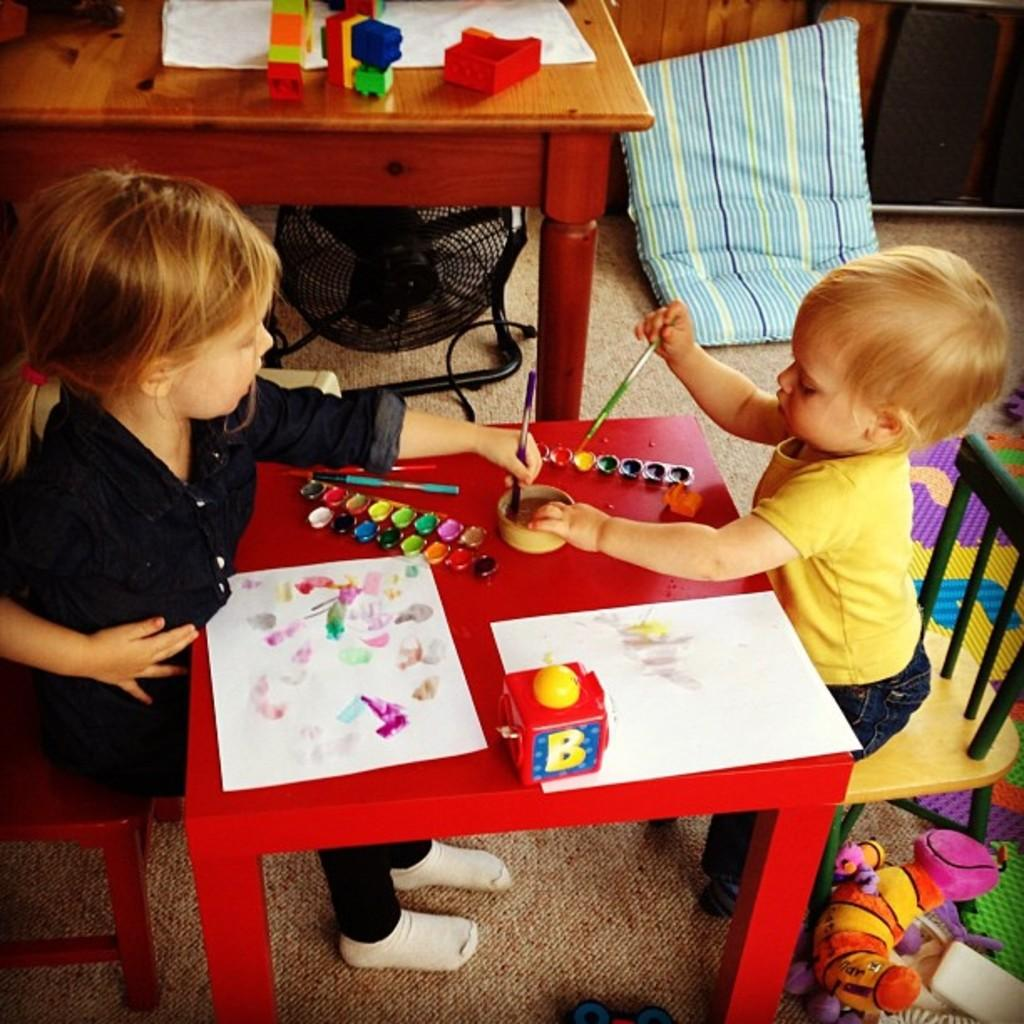What object can be seen on the floor in the image? There is a pillow on the floor in the image. What piece of furniture is present in the image? There is a table in the image. How many people are sitting in the image? There are two people sitting on chairs in the image. What is on top of the table in the image? There is a box and a paper on the table in the image. What can be observed about the table in the image? There are colors on the table in the image. How much money is on the table in the image? There is no money present on the table in the image. What type of butter is being used by the people in the image? There is no butter present in the image. 